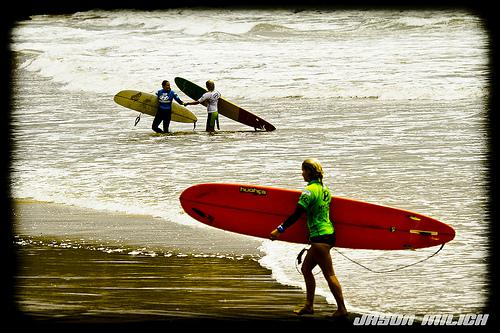Question: what are the people carrying?
Choices:
A. Surfboards.
B. Tennis rackets.
C. Balls.
D. Frisbees.
Answer with the letter. Answer: A Question: what name is on the photo?
Choices:
A. Jason Milich.
B. Brian John.
C. Tim Rote.
D. Betty  Dight.
Answer with the letter. Answer: A Question: where was the photo taken?
Choices:
A. On the Empire State Building.
B. On my back porch.
C. The beach.
D. At the pool.
Answer with the letter. Answer: C Question: what color shirt is the closest person to the camera?
Choices:
A. Green.
B. Blue.
C. Black.
D. White.
Answer with the letter. Answer: A Question: what are the two surfers in the photo doing?
Choices:
A. Giving a peace sign.
B. Shaking hands.
C. Smiling.
D. Waxing their boards.
Answer with the letter. Answer: B Question: what color is the text on the red surfboard?
Choices:
A. Yellow.
B. Black.
C. White.
D. Blue.
Answer with the letter. Answer: A 